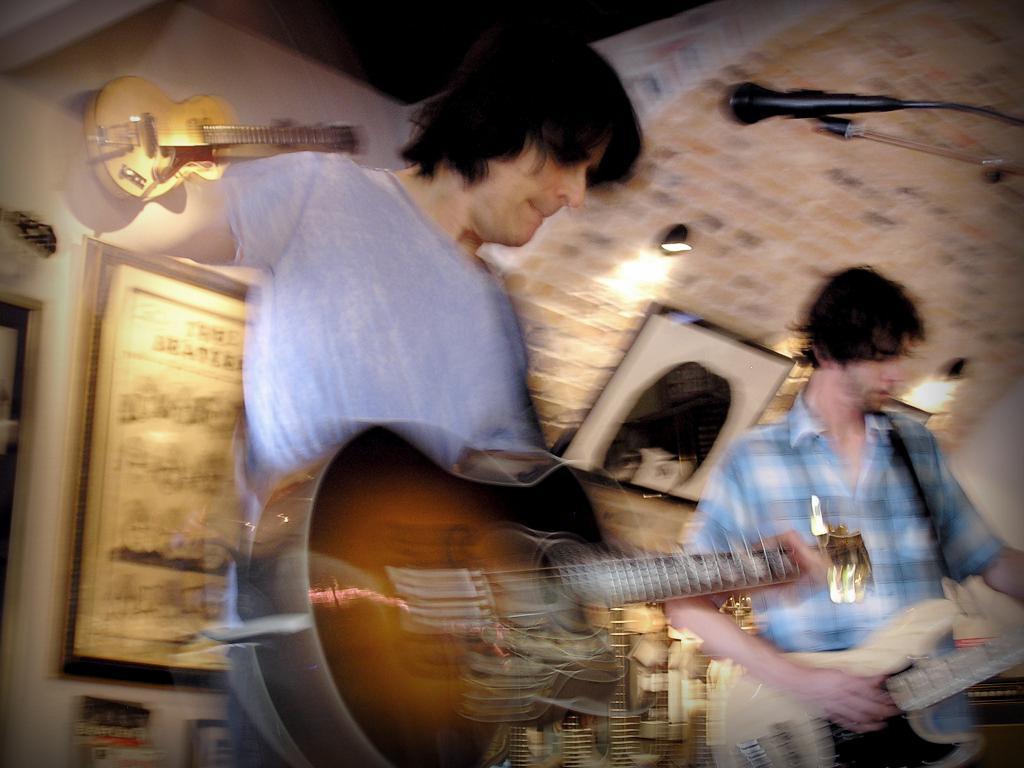Can you describe this image briefly? This image is clicked in a musical concert. There are two people in this image ,one on the right side and other one is in the middle. Both of them are playing guitar. mike is in front of the man who is in the middle behind him there is a photo frame and behind the man who is on the left also has a photo frame. There is a light on the top ,there is a guitar placed on the top of the image. 